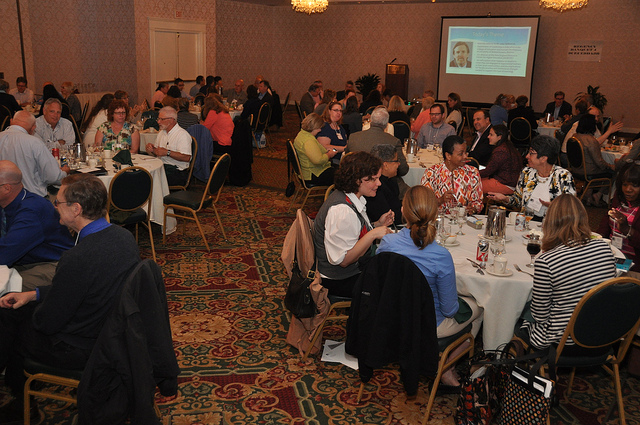How many dining tables are visible? I can see multiple dining tables occupied by guests, but due to the perspective and angles in the photo, it's not possible to count every table accurately. At least two tables are clearly visible in the foreground. 